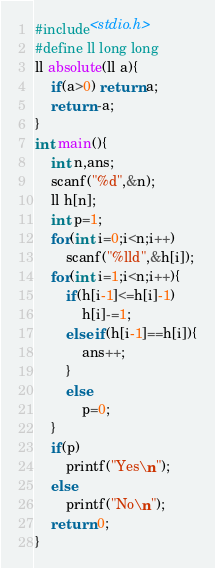Convert code to text. <code><loc_0><loc_0><loc_500><loc_500><_C_>#include<stdio.h>
#define ll long long
ll absolute(ll a){
    if(a>0) return a;
    return -a;
}
int main(){
    int n,ans;
    scanf("%d",&n);
    ll h[n];
    int p=1;
    for(int i=0;i<n;i++)
        scanf("%lld",&h[i]);
    for(int i=1;i<n;i++){
        if(h[i-1]<=h[i]-1)
            h[i]-=1;
        else if(h[i-1]==h[i]){
            ans++;
        }
        else
            p=0;
    }
    if(p)
        printf("Yes\n");
    else
        printf("No\n");
    return 0;
}</code> 